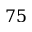<formula> <loc_0><loc_0><loc_500><loc_500>7 5</formula> 